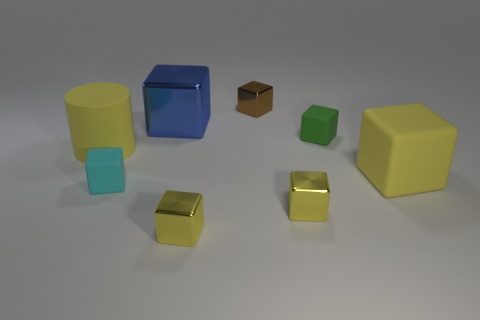Can you describe the setting where these objects are placed? The objects are arranged on a flat surface that appears to be smooth and even, possibly made of metal or plastic. The background is nondescript, with a neutral grey color that doesn't draw attention away from the objects. The lighting is soft and diffused, casting gentle shadows under each object, adding to a sense of three-dimensionality and space. 